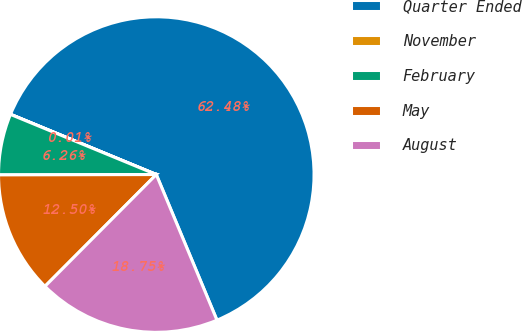<chart> <loc_0><loc_0><loc_500><loc_500><pie_chart><fcel>Quarter Ended<fcel>November<fcel>February<fcel>May<fcel>August<nl><fcel>62.48%<fcel>0.01%<fcel>6.26%<fcel>12.5%<fcel>18.75%<nl></chart> 